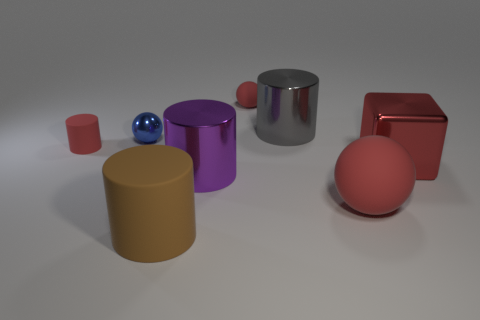The big shiny object that is the same color as the small matte sphere is what shape?
Make the answer very short. Cube. What is the color of the large rubber cylinder?
Provide a short and direct response. Brown. Does the red thing that is to the left of the tiny blue thing have the same shape as the large shiny object that is to the right of the large red sphere?
Your response must be concise. No. There is a large matte object behind the brown object; what is its color?
Make the answer very short. Red. Is the number of blue shiny balls that are right of the large gray cylinder less than the number of things that are right of the big cube?
Provide a short and direct response. No. Does the tiny red sphere have the same material as the big gray cylinder?
Provide a short and direct response. No. How many other things are the same size as the purple shiny cylinder?
Give a very brief answer. 4. There is a rubber sphere behind the cylinder behind the small blue ball; what is its size?
Offer a terse response. Small. What color is the big matte object that is in front of the sphere that is in front of the matte object left of the brown cylinder?
Provide a succinct answer. Brown. There is a cylinder that is behind the large brown object and in front of the red block; what size is it?
Your answer should be compact. Large. 